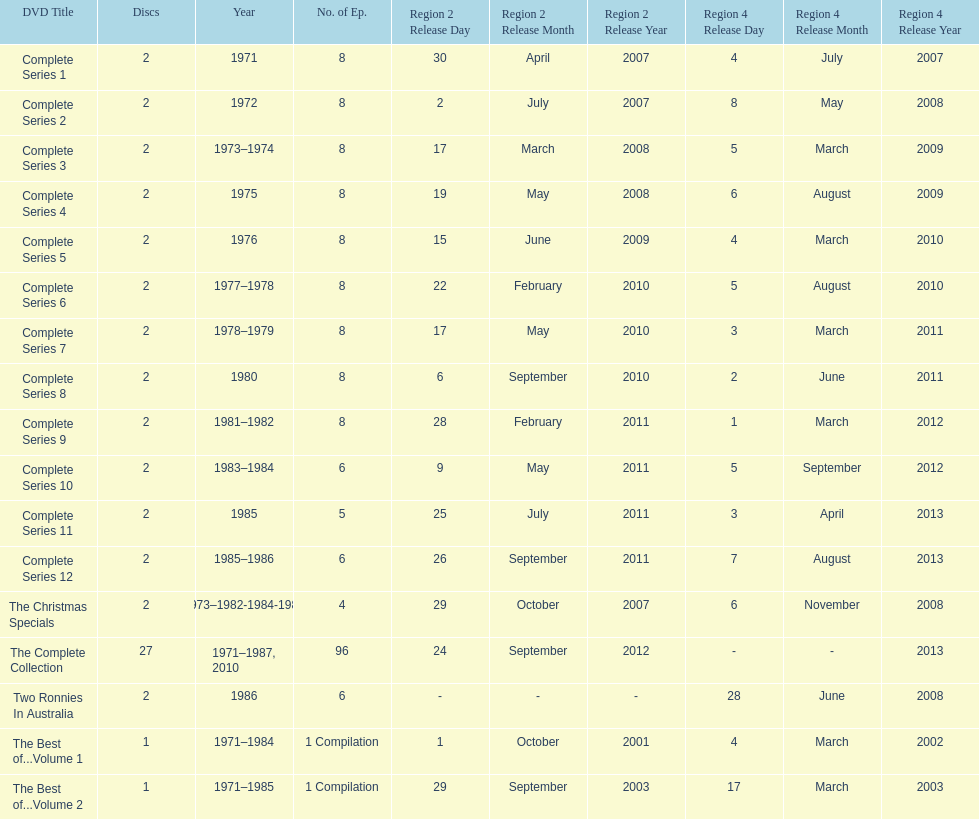True or false. the television show "the two ronnies" featured more than 10 episodes in a season. False. 